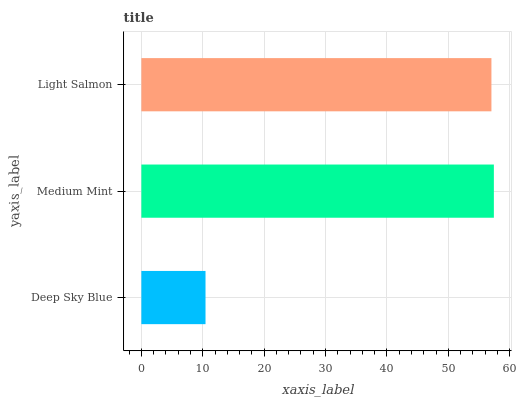Is Deep Sky Blue the minimum?
Answer yes or no. Yes. Is Medium Mint the maximum?
Answer yes or no. Yes. Is Light Salmon the minimum?
Answer yes or no. No. Is Light Salmon the maximum?
Answer yes or no. No. Is Medium Mint greater than Light Salmon?
Answer yes or no. Yes. Is Light Salmon less than Medium Mint?
Answer yes or no. Yes. Is Light Salmon greater than Medium Mint?
Answer yes or no. No. Is Medium Mint less than Light Salmon?
Answer yes or no. No. Is Light Salmon the high median?
Answer yes or no. Yes. Is Light Salmon the low median?
Answer yes or no. Yes. Is Medium Mint the high median?
Answer yes or no. No. Is Deep Sky Blue the low median?
Answer yes or no. No. 